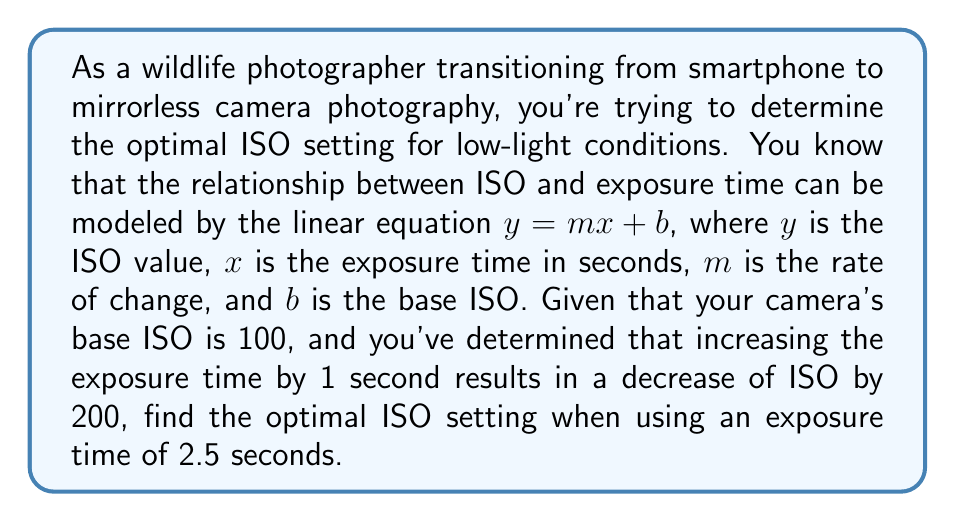Teach me how to tackle this problem. Let's approach this step-by-step:

1) We're given the linear equation form: $y = mx + b$

2) We know:
   - $b = 100$ (base ISO)
   - When $x$ increases by 1, $y$ decreases by 200

3) To find $m$ (rate of change):
   $$m = \frac{\text{change in y}}{\text{change in x}} = \frac{-200}{1} = -200$$

4) Now we have the equation:
   $$y = -200x + 100$$

5) To find the ISO (y) when exposure time (x) is 2.5 seconds:
   $$y = -200(2.5) + 100$$
   $$y = -500 + 100$$
   $$y = -400$$

6) However, ISO cannot be negative. This means we've reached the lower limit of the ISO range. In practice, the lowest ISO setting is typically 100.

Therefore, the optimal ISO setting for an exposure time of 2.5 seconds in these conditions would be 100.
Answer: 100 